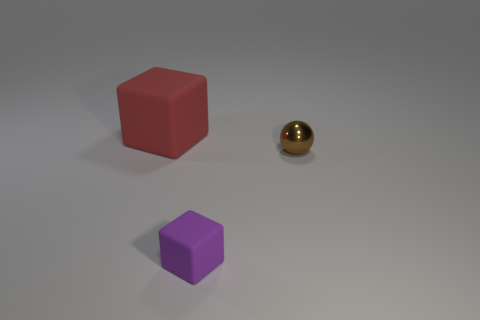Is there anything else that is the same material as the tiny brown ball?
Offer a very short reply. No. What material is the tiny brown sphere in front of the rubber thing that is to the left of the cube that is in front of the tiny brown metal thing made of?
Offer a very short reply. Metal. Does the large red matte thing have the same shape as the brown shiny thing?
Offer a very short reply. No. What number of matte things are either tiny brown balls or big yellow balls?
Offer a terse response. 0. What number of small purple matte objects are there?
Your answer should be very brief. 1. There is a cube that is the same size as the brown object; what color is it?
Your answer should be compact. Purple. Do the purple thing and the red object have the same size?
Offer a terse response. No. There is a red cube; does it have the same size as the matte cube that is in front of the large red cube?
Provide a succinct answer. No. There is a thing that is behind the purple thing and to the right of the big red matte block; what color is it?
Ensure brevity in your answer.  Brown. Are there more tiny shiny objects behind the purple matte block than things right of the tiny brown metal ball?
Give a very brief answer. Yes. 